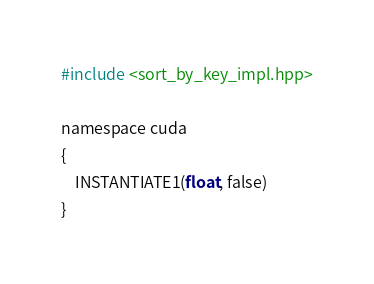<code> <loc_0><loc_0><loc_500><loc_500><_Cuda_>#include <sort_by_key_impl.hpp>

namespace cuda
{
    INSTANTIATE1(float, false)
}
</code> 